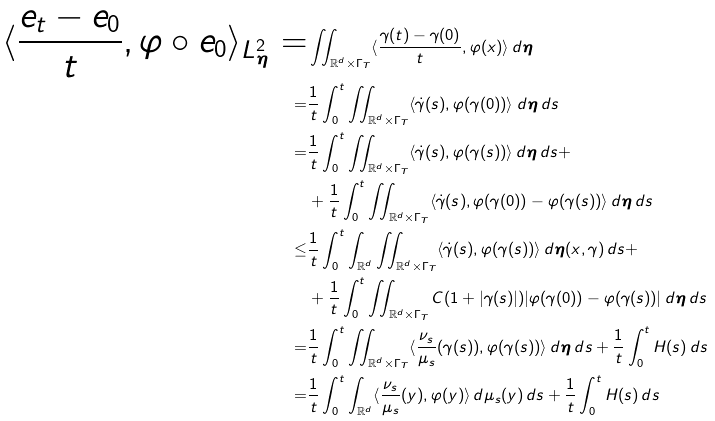Convert formula to latex. <formula><loc_0><loc_0><loc_500><loc_500>\langle \frac { e _ { t } - e _ { 0 } } { t } , \varphi \circ e _ { 0 } \rangle _ { L ^ { 2 } _ { \boldsymbol \eta } } = & \iint _ { \mathbb { R } ^ { d } \times \Gamma _ { T } } \langle \frac { \gamma ( t ) - \gamma ( 0 ) } { t } , \varphi ( x ) \rangle \, d \boldsymbol \eta \\ = & \frac { 1 } { t } \int _ { 0 } ^ { t } \iint _ { \mathbb { R } ^ { d } \times \Gamma _ { T } } \langle \dot { \gamma } ( s ) , \varphi ( \gamma ( 0 ) ) \rangle \, d \boldsymbol \eta \, d s \\ = & \frac { 1 } { t } \int _ { 0 } ^ { t } \iint _ { \mathbb { R } ^ { d } \times \Gamma _ { T } } \langle \dot { \gamma } ( s ) , \varphi ( \gamma ( s ) ) \rangle \, d \boldsymbol \eta \, d s + \\ & + \frac { 1 } { t } \int _ { 0 } ^ { t } \iint _ { \mathbb { R } ^ { d } \times \Gamma _ { T } } \langle \dot { \gamma } ( s ) , \varphi ( \gamma ( 0 ) ) - \varphi ( \gamma ( s ) ) \rangle \, d \boldsymbol \eta \, d s \\ \leq & \frac { 1 } { t } \int _ { 0 } ^ { t } \int _ { \mathbb { R } ^ { d } } \iint _ { \mathbb { R } ^ { d } \times \Gamma _ { T } } \langle \dot { \gamma } ( s ) , \varphi ( \gamma ( s ) ) \rangle \, d \boldsymbol \eta ( x , \gamma ) \, d s + \\ & + \frac { 1 } { t } \int _ { 0 } ^ { t } \iint _ { \mathbb { R } ^ { d } \times \Gamma _ { T } } C ( 1 + | \gamma ( s ) | ) | \varphi ( \gamma ( 0 ) ) - \varphi ( \gamma ( s ) ) | \, d \boldsymbol \eta \, d s \\ = & \frac { 1 } { t } \int _ { 0 } ^ { t } \iint _ { \mathbb { R } ^ { d } \times \Gamma _ { T } } \langle \frac { \nu _ { s } } { \mu _ { s } } ( \gamma ( s ) ) , \varphi ( \gamma ( s ) ) \rangle \, d \boldsymbol \eta \, d s + \frac { 1 } { t } \int _ { 0 } ^ { t } H ( s ) \, d s \\ = & \frac { 1 } { t } \int _ { 0 } ^ { t } \int _ { \mathbb { R } ^ { d } } \langle \frac { \nu _ { s } } { \mu _ { s } } ( y ) , \varphi ( y ) \rangle \, d \mu _ { s } ( y ) \, d s + \frac { 1 } { t } \int _ { 0 } ^ { t } H ( s ) \, d s</formula> 